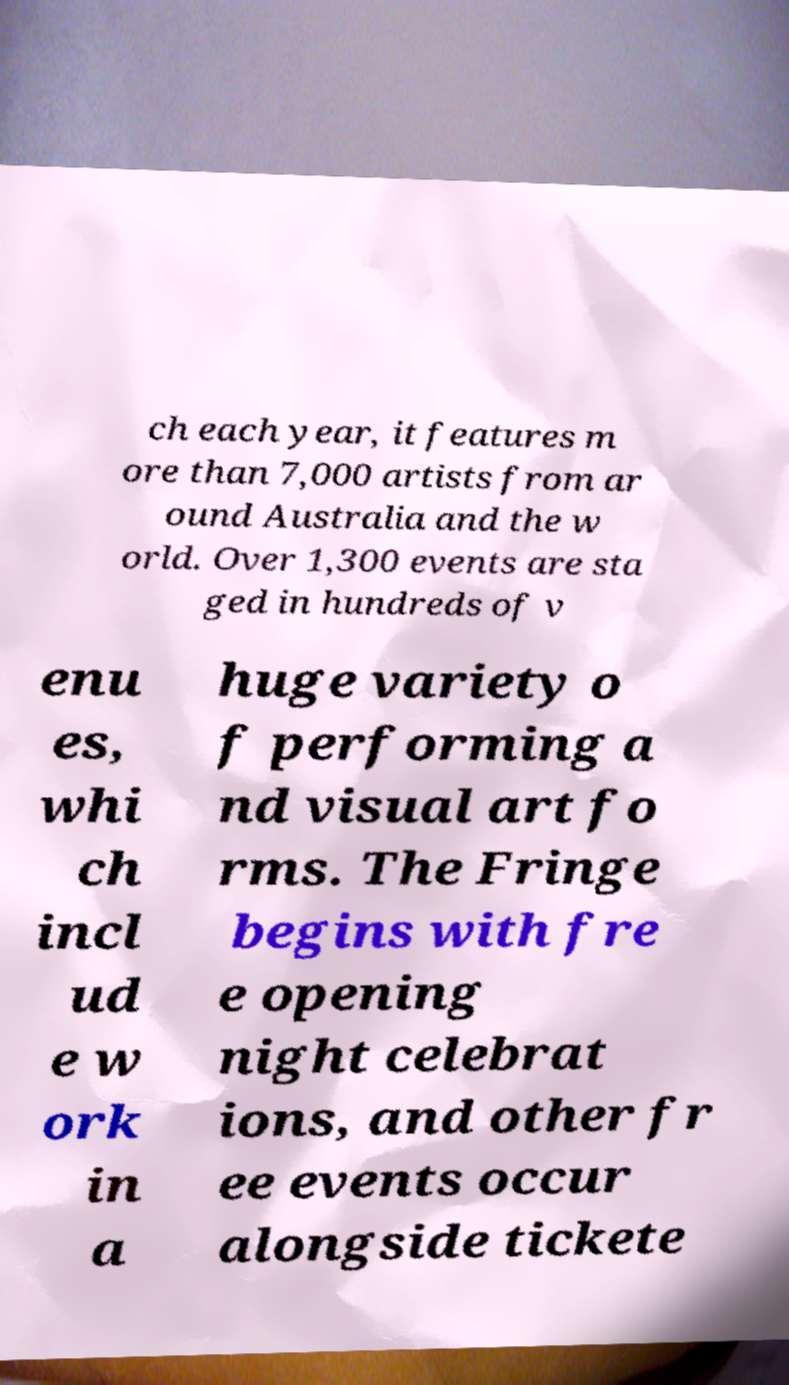I need the written content from this picture converted into text. Can you do that? ch each year, it features m ore than 7,000 artists from ar ound Australia and the w orld. Over 1,300 events are sta ged in hundreds of v enu es, whi ch incl ud e w ork in a huge variety o f performing a nd visual art fo rms. The Fringe begins with fre e opening night celebrat ions, and other fr ee events occur alongside tickete 